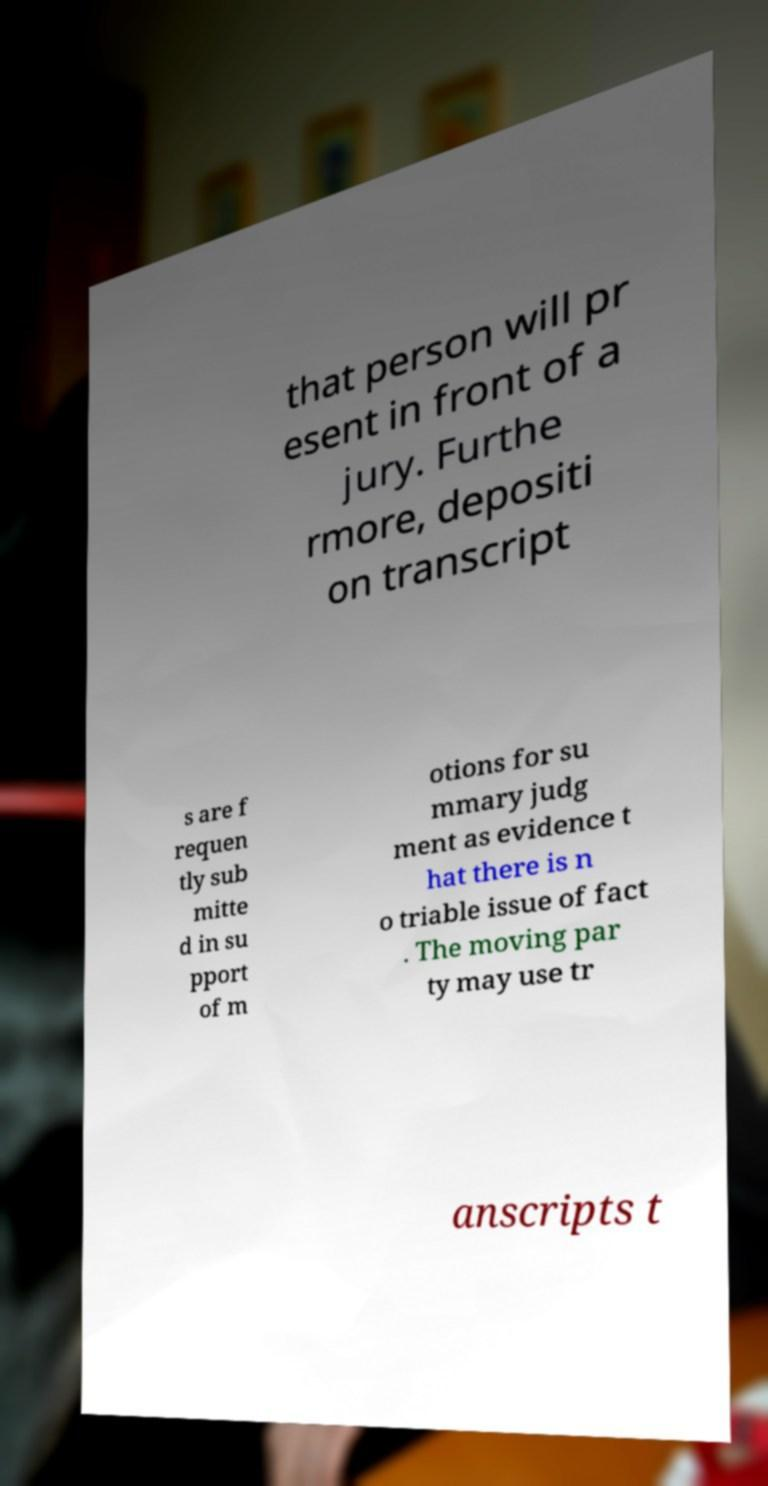I need the written content from this picture converted into text. Can you do that? that person will pr esent in front of a jury. Furthe rmore, depositi on transcript s are f requen tly sub mitte d in su pport of m otions for su mmary judg ment as evidence t hat there is n o triable issue of fact . The moving par ty may use tr anscripts t 